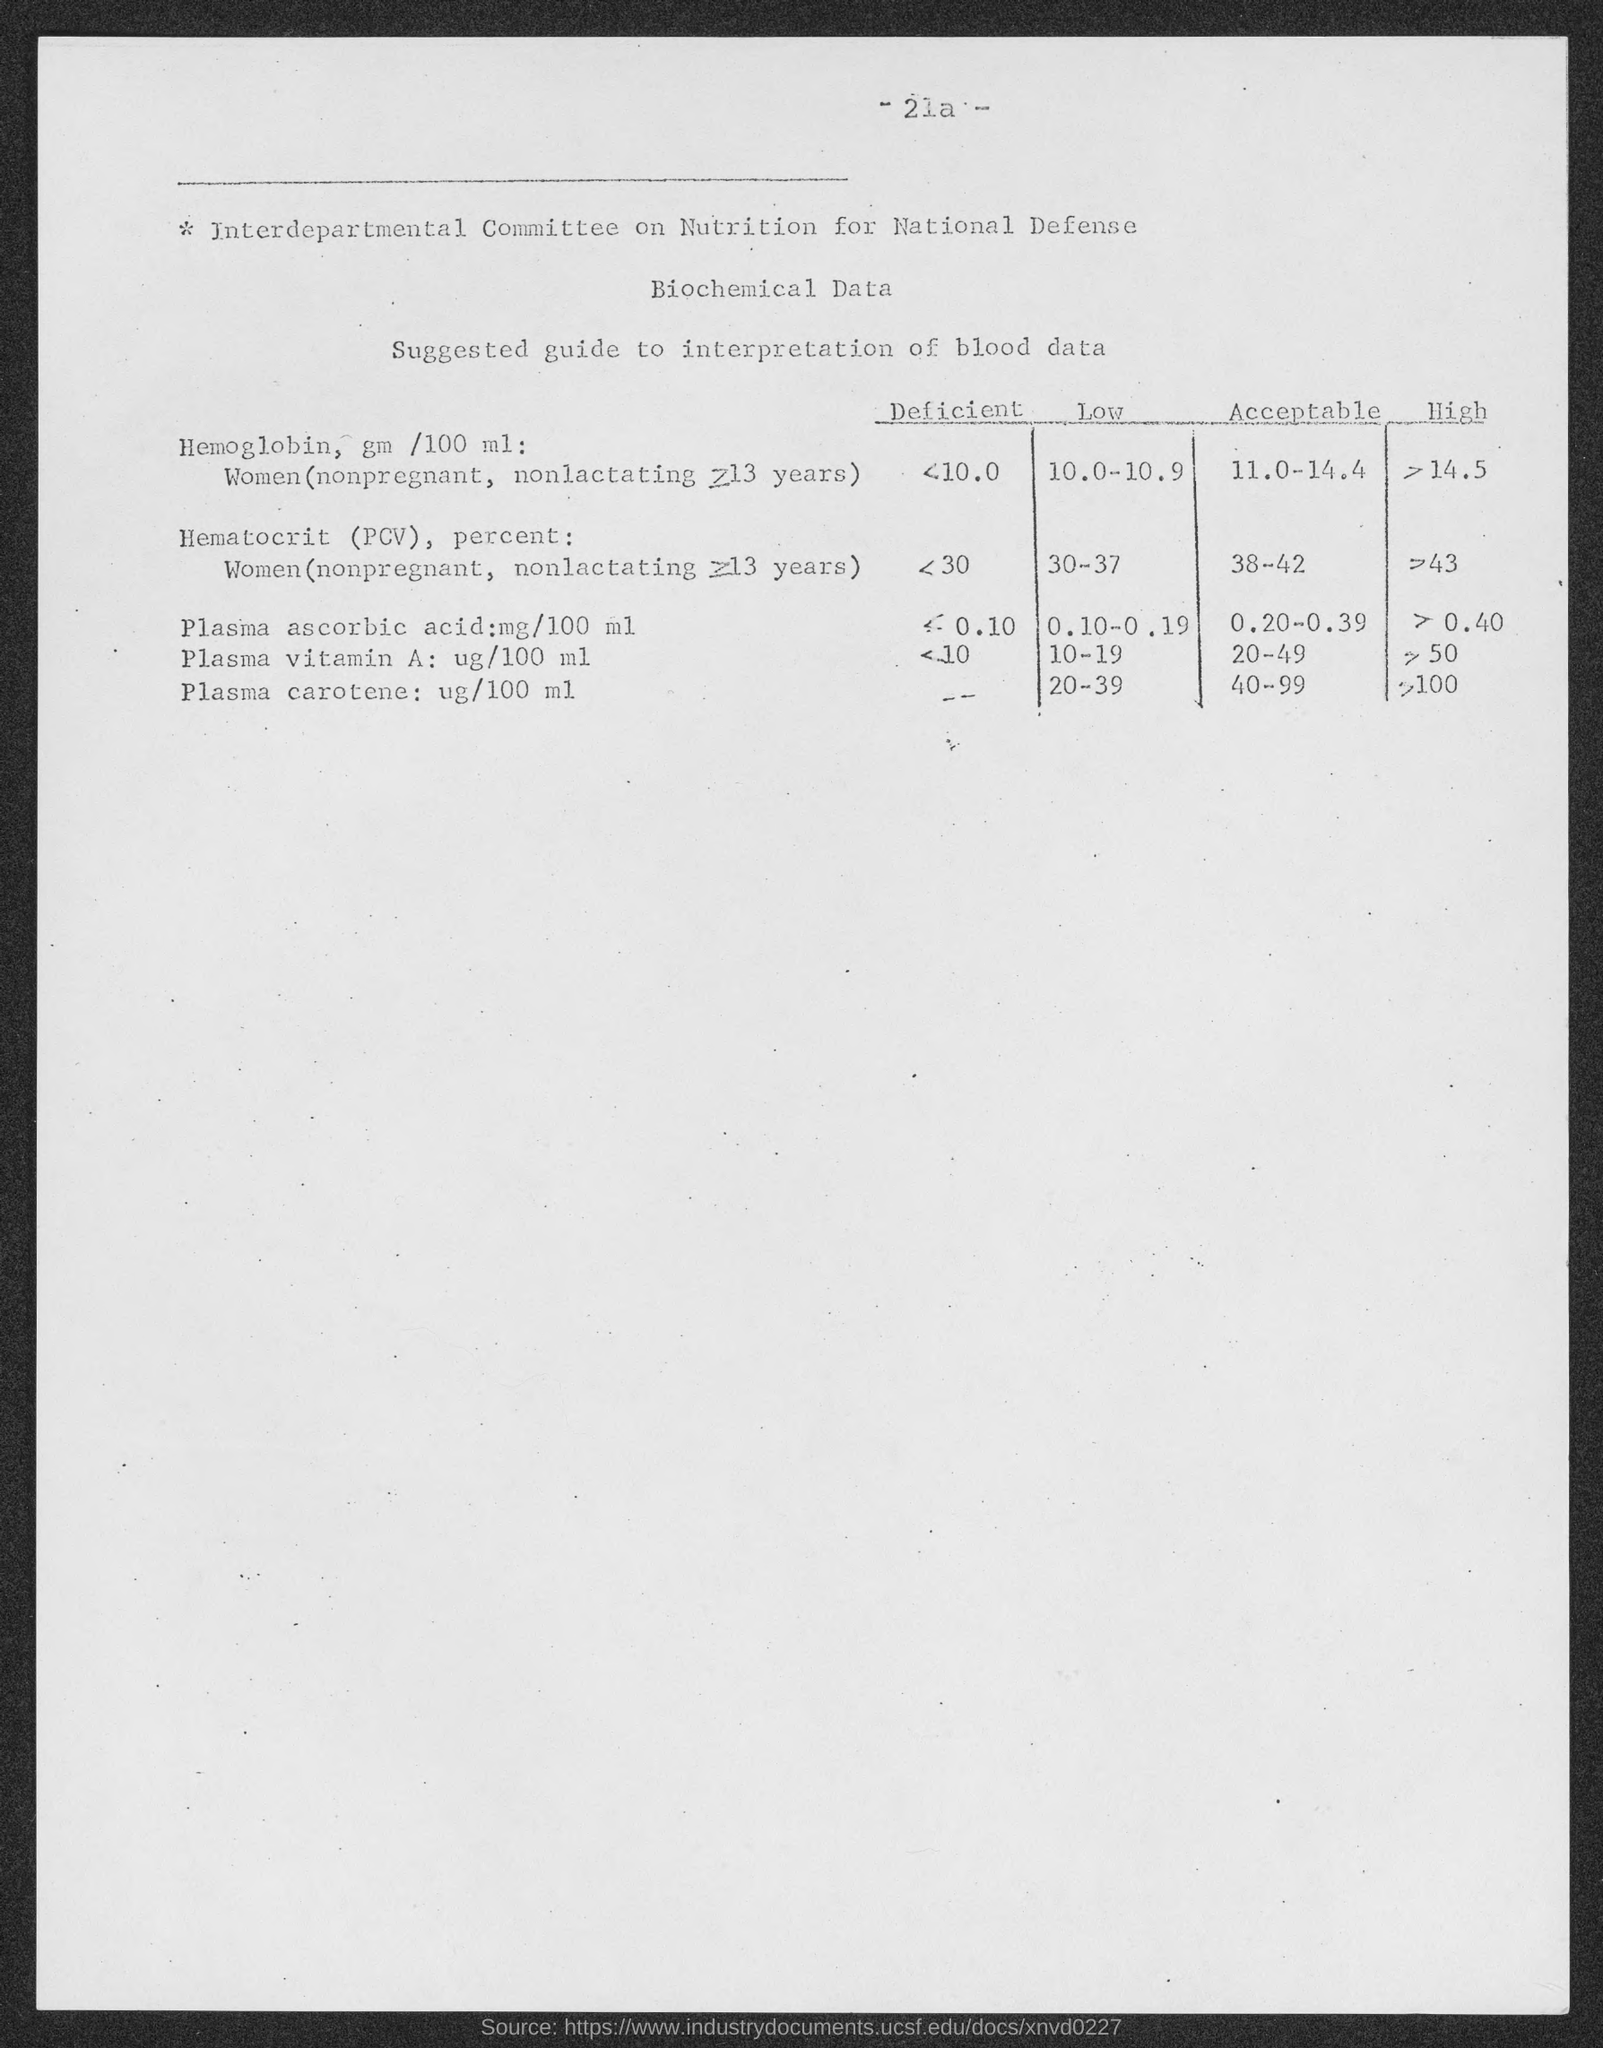Mention a couple of crucial points in this snapshot. What is the page number?" is a question asking for information about a page number. "21a" is a reference to a page number, and "...". is a continuation of the request for information. 